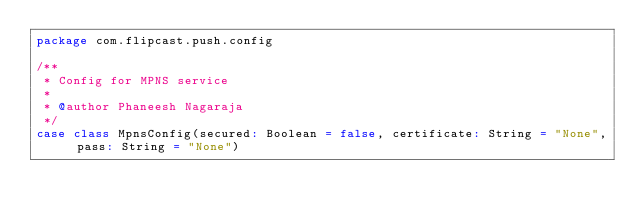Convert code to text. <code><loc_0><loc_0><loc_500><loc_500><_Scala_>package com.flipcast.push.config

/**
 * Config for MPNS service
 *
 * @author Phaneesh Nagaraja
 */
case class MpnsConfig(secured: Boolean = false, certificate: String = "None", pass: String = "None")
</code> 